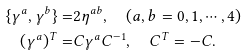Convert formula to latex. <formula><loc_0><loc_0><loc_500><loc_500>\{ \gamma ^ { a } , \gamma ^ { b } \} = & 2 \eta ^ { a b } , \quad ( a , b = 0 , 1 , \cdots , 4 ) \\ ( \gamma ^ { a } ) ^ { T } = & C \gamma ^ { a } C ^ { - 1 } , \quad C ^ { T } = - C .</formula> 